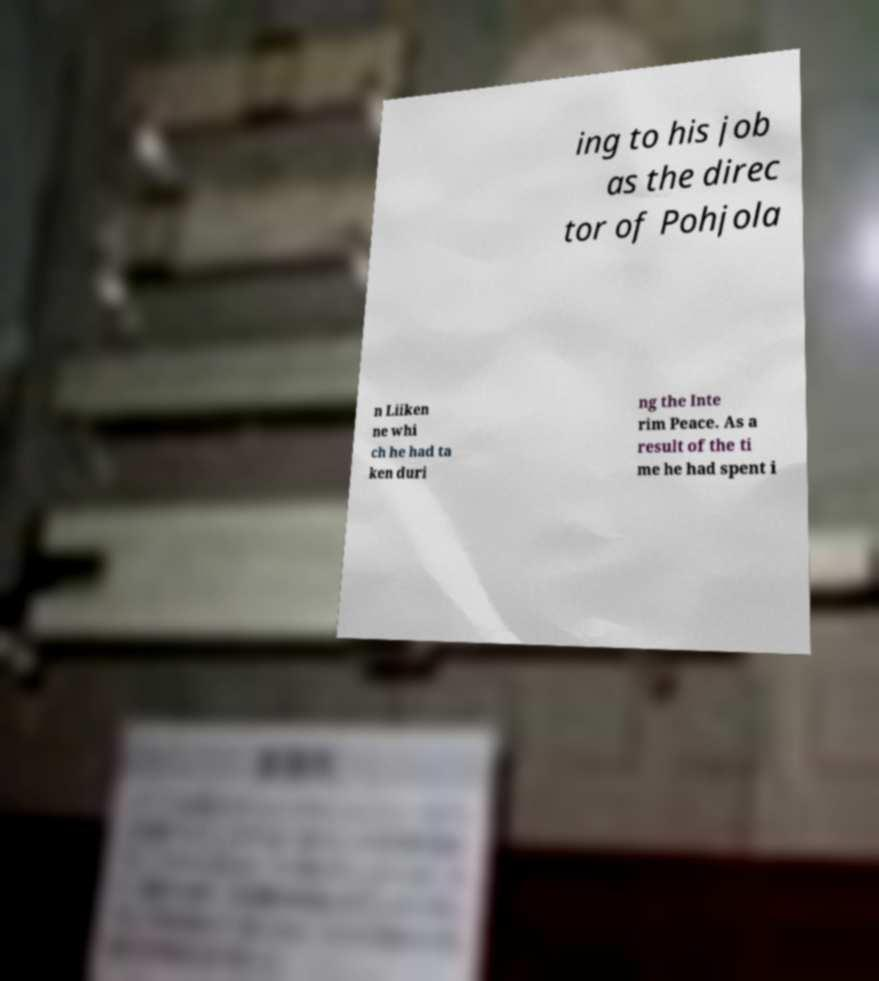For documentation purposes, I need the text within this image transcribed. Could you provide that? ing to his job as the direc tor of Pohjola n Liiken ne whi ch he had ta ken duri ng the Inte rim Peace. As a result of the ti me he had spent i 